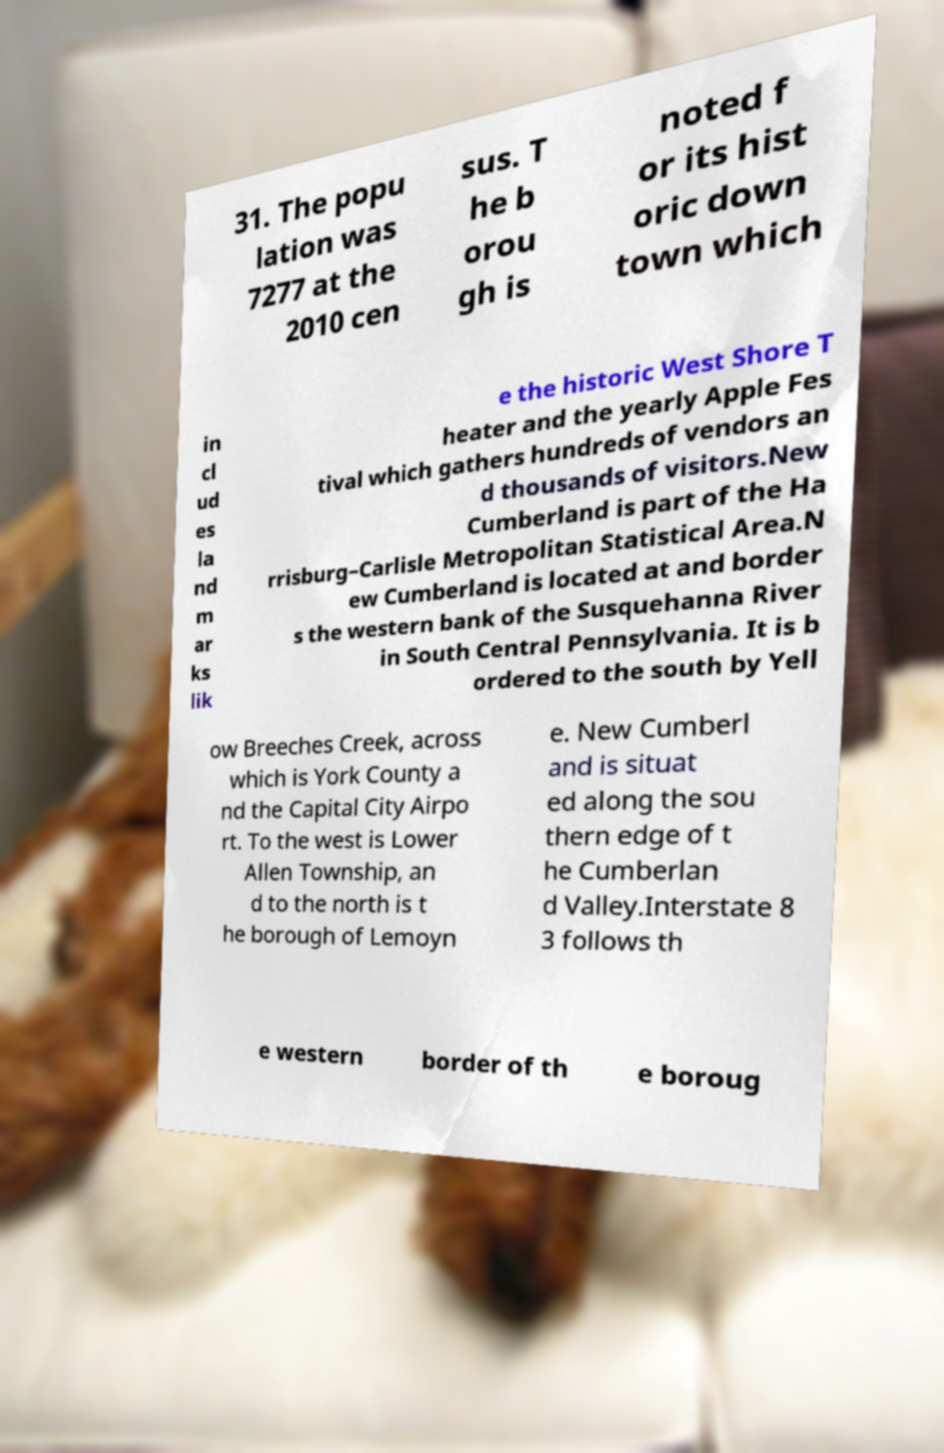What messages or text are displayed in this image? I need them in a readable, typed format. 31. The popu lation was 7277 at the 2010 cen sus. T he b orou gh is noted f or its hist oric down town which in cl ud es la nd m ar ks lik e the historic West Shore T heater and the yearly Apple Fes tival which gathers hundreds of vendors an d thousands of visitors.New Cumberland is part of the Ha rrisburg–Carlisle Metropolitan Statistical Area.N ew Cumberland is located at and border s the western bank of the Susquehanna River in South Central Pennsylvania. It is b ordered to the south by Yell ow Breeches Creek, across which is York County a nd the Capital City Airpo rt. To the west is Lower Allen Township, an d to the north is t he borough of Lemoyn e. New Cumberl and is situat ed along the sou thern edge of t he Cumberlan d Valley.Interstate 8 3 follows th e western border of th e boroug 